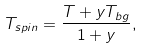<formula> <loc_0><loc_0><loc_500><loc_500>T _ { s p i n } = \frac { T + y T _ { b g } } { 1 + y } ,</formula> 